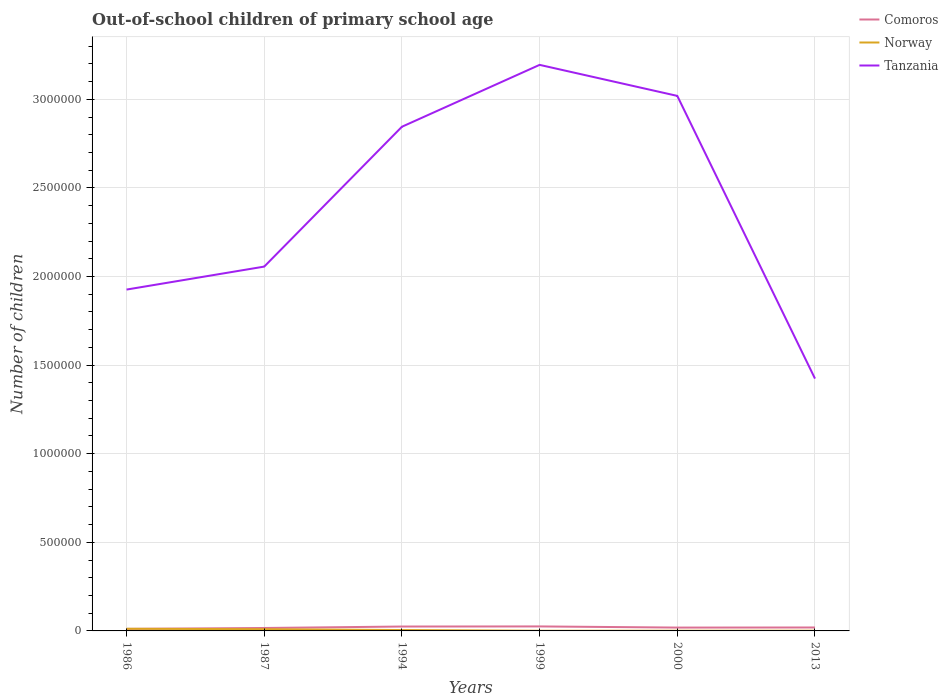Is the number of lines equal to the number of legend labels?
Your response must be concise. Yes. Across all years, what is the maximum number of out-of-school children in Tanzania?
Keep it short and to the point. 1.42e+06. In which year was the number of out-of-school children in Tanzania maximum?
Provide a succinct answer. 2013. What is the total number of out-of-school children in Comoros in the graph?
Offer a very short reply. -2769. What is the difference between the highest and the second highest number of out-of-school children in Tanzania?
Your response must be concise. 1.77e+06. Is the number of out-of-school children in Comoros strictly greater than the number of out-of-school children in Tanzania over the years?
Your response must be concise. Yes. How many lines are there?
Make the answer very short. 3. Does the graph contain grids?
Provide a short and direct response. Yes. How are the legend labels stacked?
Your answer should be compact. Vertical. What is the title of the graph?
Your answer should be very brief. Out-of-school children of primary school age. What is the label or title of the X-axis?
Keep it short and to the point. Years. What is the label or title of the Y-axis?
Offer a very short reply. Number of children. What is the Number of children of Comoros in 1986?
Provide a succinct answer. 1.14e+04. What is the Number of children in Norway in 1986?
Make the answer very short. 1.22e+04. What is the Number of children of Tanzania in 1986?
Offer a very short reply. 1.93e+06. What is the Number of children of Comoros in 1987?
Make the answer very short. 1.66e+04. What is the Number of children in Norway in 1987?
Give a very brief answer. 9681. What is the Number of children in Tanzania in 1987?
Your answer should be very brief. 2.06e+06. What is the Number of children of Comoros in 1994?
Give a very brief answer. 2.48e+04. What is the Number of children in Norway in 1994?
Your answer should be compact. 4983. What is the Number of children in Tanzania in 1994?
Offer a terse response. 2.85e+06. What is the Number of children in Comoros in 1999?
Your response must be concise. 2.54e+04. What is the Number of children in Norway in 1999?
Provide a succinct answer. 908. What is the Number of children in Tanzania in 1999?
Give a very brief answer. 3.19e+06. What is the Number of children in Comoros in 2000?
Provide a short and direct response. 1.89e+04. What is the Number of children of Norway in 2000?
Offer a terse response. 1169. What is the Number of children in Tanzania in 2000?
Keep it short and to the point. 3.02e+06. What is the Number of children in Comoros in 2013?
Offer a very short reply. 1.94e+04. What is the Number of children in Norway in 2013?
Provide a short and direct response. 1232. What is the Number of children in Tanzania in 2013?
Your response must be concise. 1.42e+06. Across all years, what is the maximum Number of children of Comoros?
Provide a succinct answer. 2.54e+04. Across all years, what is the maximum Number of children of Norway?
Your answer should be very brief. 1.22e+04. Across all years, what is the maximum Number of children in Tanzania?
Provide a short and direct response. 3.19e+06. Across all years, what is the minimum Number of children in Comoros?
Your answer should be very brief. 1.14e+04. Across all years, what is the minimum Number of children of Norway?
Ensure brevity in your answer.  908. Across all years, what is the minimum Number of children of Tanzania?
Provide a succinct answer. 1.42e+06. What is the total Number of children of Comoros in the graph?
Offer a very short reply. 1.16e+05. What is the total Number of children in Norway in the graph?
Your answer should be very brief. 3.01e+04. What is the total Number of children of Tanzania in the graph?
Your response must be concise. 1.45e+07. What is the difference between the Number of children of Comoros in 1986 and that in 1987?
Give a very brief answer. -5165. What is the difference between the Number of children in Norway in 1986 and that in 1987?
Offer a terse response. 2478. What is the difference between the Number of children in Tanzania in 1986 and that in 1987?
Provide a succinct answer. -1.30e+05. What is the difference between the Number of children of Comoros in 1986 and that in 1994?
Offer a very short reply. -1.34e+04. What is the difference between the Number of children in Norway in 1986 and that in 1994?
Make the answer very short. 7176. What is the difference between the Number of children in Tanzania in 1986 and that in 1994?
Provide a short and direct response. -9.19e+05. What is the difference between the Number of children in Comoros in 1986 and that in 1999?
Provide a short and direct response. -1.39e+04. What is the difference between the Number of children in Norway in 1986 and that in 1999?
Make the answer very short. 1.13e+04. What is the difference between the Number of children of Tanzania in 1986 and that in 1999?
Your answer should be very brief. -1.27e+06. What is the difference between the Number of children in Comoros in 1986 and that in 2000?
Give a very brief answer. -7472. What is the difference between the Number of children of Norway in 1986 and that in 2000?
Provide a short and direct response. 1.10e+04. What is the difference between the Number of children in Tanzania in 1986 and that in 2000?
Offer a terse response. -1.09e+06. What is the difference between the Number of children of Comoros in 1986 and that in 2013?
Make the answer very short. -7934. What is the difference between the Number of children of Norway in 1986 and that in 2013?
Provide a short and direct response. 1.09e+04. What is the difference between the Number of children of Tanzania in 1986 and that in 2013?
Offer a very short reply. 5.02e+05. What is the difference between the Number of children in Comoros in 1987 and that in 1994?
Provide a succinct answer. -8191. What is the difference between the Number of children in Norway in 1987 and that in 1994?
Ensure brevity in your answer.  4698. What is the difference between the Number of children in Tanzania in 1987 and that in 1994?
Your answer should be compact. -7.89e+05. What is the difference between the Number of children in Comoros in 1987 and that in 1999?
Provide a short and direct response. -8778. What is the difference between the Number of children in Norway in 1987 and that in 1999?
Offer a very short reply. 8773. What is the difference between the Number of children of Tanzania in 1987 and that in 1999?
Your answer should be very brief. -1.14e+06. What is the difference between the Number of children in Comoros in 1987 and that in 2000?
Keep it short and to the point. -2307. What is the difference between the Number of children of Norway in 1987 and that in 2000?
Your answer should be very brief. 8512. What is the difference between the Number of children of Tanzania in 1987 and that in 2000?
Your response must be concise. -9.63e+05. What is the difference between the Number of children of Comoros in 1987 and that in 2013?
Offer a very short reply. -2769. What is the difference between the Number of children in Norway in 1987 and that in 2013?
Offer a terse response. 8449. What is the difference between the Number of children of Tanzania in 1987 and that in 2013?
Your answer should be very brief. 6.32e+05. What is the difference between the Number of children of Comoros in 1994 and that in 1999?
Offer a terse response. -587. What is the difference between the Number of children of Norway in 1994 and that in 1999?
Give a very brief answer. 4075. What is the difference between the Number of children in Tanzania in 1994 and that in 1999?
Offer a very short reply. -3.49e+05. What is the difference between the Number of children of Comoros in 1994 and that in 2000?
Keep it short and to the point. 5884. What is the difference between the Number of children of Norway in 1994 and that in 2000?
Your response must be concise. 3814. What is the difference between the Number of children in Tanzania in 1994 and that in 2000?
Give a very brief answer. -1.74e+05. What is the difference between the Number of children of Comoros in 1994 and that in 2013?
Your answer should be very brief. 5422. What is the difference between the Number of children in Norway in 1994 and that in 2013?
Make the answer very short. 3751. What is the difference between the Number of children of Tanzania in 1994 and that in 2013?
Your response must be concise. 1.42e+06. What is the difference between the Number of children in Comoros in 1999 and that in 2000?
Offer a terse response. 6471. What is the difference between the Number of children of Norway in 1999 and that in 2000?
Ensure brevity in your answer.  -261. What is the difference between the Number of children of Tanzania in 1999 and that in 2000?
Offer a very short reply. 1.75e+05. What is the difference between the Number of children in Comoros in 1999 and that in 2013?
Offer a terse response. 6009. What is the difference between the Number of children in Norway in 1999 and that in 2013?
Ensure brevity in your answer.  -324. What is the difference between the Number of children in Tanzania in 1999 and that in 2013?
Your response must be concise. 1.77e+06. What is the difference between the Number of children of Comoros in 2000 and that in 2013?
Provide a short and direct response. -462. What is the difference between the Number of children of Norway in 2000 and that in 2013?
Give a very brief answer. -63. What is the difference between the Number of children of Tanzania in 2000 and that in 2013?
Your answer should be compact. 1.60e+06. What is the difference between the Number of children in Comoros in 1986 and the Number of children in Norway in 1987?
Your answer should be very brief. 1742. What is the difference between the Number of children in Comoros in 1986 and the Number of children in Tanzania in 1987?
Give a very brief answer. -2.04e+06. What is the difference between the Number of children in Norway in 1986 and the Number of children in Tanzania in 1987?
Your answer should be very brief. -2.04e+06. What is the difference between the Number of children in Comoros in 1986 and the Number of children in Norway in 1994?
Your answer should be compact. 6440. What is the difference between the Number of children of Comoros in 1986 and the Number of children of Tanzania in 1994?
Your response must be concise. -2.83e+06. What is the difference between the Number of children in Norway in 1986 and the Number of children in Tanzania in 1994?
Your answer should be very brief. -2.83e+06. What is the difference between the Number of children in Comoros in 1986 and the Number of children in Norway in 1999?
Provide a short and direct response. 1.05e+04. What is the difference between the Number of children of Comoros in 1986 and the Number of children of Tanzania in 1999?
Ensure brevity in your answer.  -3.18e+06. What is the difference between the Number of children in Norway in 1986 and the Number of children in Tanzania in 1999?
Ensure brevity in your answer.  -3.18e+06. What is the difference between the Number of children in Comoros in 1986 and the Number of children in Norway in 2000?
Provide a short and direct response. 1.03e+04. What is the difference between the Number of children of Comoros in 1986 and the Number of children of Tanzania in 2000?
Keep it short and to the point. -3.01e+06. What is the difference between the Number of children in Norway in 1986 and the Number of children in Tanzania in 2000?
Offer a terse response. -3.01e+06. What is the difference between the Number of children of Comoros in 1986 and the Number of children of Norway in 2013?
Ensure brevity in your answer.  1.02e+04. What is the difference between the Number of children in Comoros in 1986 and the Number of children in Tanzania in 2013?
Offer a terse response. -1.41e+06. What is the difference between the Number of children in Norway in 1986 and the Number of children in Tanzania in 2013?
Provide a succinct answer. -1.41e+06. What is the difference between the Number of children in Comoros in 1987 and the Number of children in Norway in 1994?
Keep it short and to the point. 1.16e+04. What is the difference between the Number of children in Comoros in 1987 and the Number of children in Tanzania in 1994?
Your answer should be very brief. -2.83e+06. What is the difference between the Number of children of Norway in 1987 and the Number of children of Tanzania in 1994?
Make the answer very short. -2.84e+06. What is the difference between the Number of children of Comoros in 1987 and the Number of children of Norway in 1999?
Your response must be concise. 1.57e+04. What is the difference between the Number of children of Comoros in 1987 and the Number of children of Tanzania in 1999?
Offer a very short reply. -3.18e+06. What is the difference between the Number of children of Norway in 1987 and the Number of children of Tanzania in 1999?
Provide a short and direct response. -3.18e+06. What is the difference between the Number of children of Comoros in 1987 and the Number of children of Norway in 2000?
Your response must be concise. 1.54e+04. What is the difference between the Number of children of Comoros in 1987 and the Number of children of Tanzania in 2000?
Keep it short and to the point. -3.00e+06. What is the difference between the Number of children in Norway in 1987 and the Number of children in Tanzania in 2000?
Provide a succinct answer. -3.01e+06. What is the difference between the Number of children in Comoros in 1987 and the Number of children in Norway in 2013?
Offer a very short reply. 1.54e+04. What is the difference between the Number of children in Comoros in 1987 and the Number of children in Tanzania in 2013?
Provide a succinct answer. -1.41e+06. What is the difference between the Number of children of Norway in 1987 and the Number of children of Tanzania in 2013?
Your response must be concise. -1.41e+06. What is the difference between the Number of children of Comoros in 1994 and the Number of children of Norway in 1999?
Offer a terse response. 2.39e+04. What is the difference between the Number of children of Comoros in 1994 and the Number of children of Tanzania in 1999?
Keep it short and to the point. -3.17e+06. What is the difference between the Number of children in Norway in 1994 and the Number of children in Tanzania in 1999?
Make the answer very short. -3.19e+06. What is the difference between the Number of children of Comoros in 1994 and the Number of children of Norway in 2000?
Your response must be concise. 2.36e+04. What is the difference between the Number of children in Comoros in 1994 and the Number of children in Tanzania in 2000?
Keep it short and to the point. -2.99e+06. What is the difference between the Number of children in Norway in 1994 and the Number of children in Tanzania in 2000?
Your answer should be compact. -3.01e+06. What is the difference between the Number of children in Comoros in 1994 and the Number of children in Norway in 2013?
Your answer should be very brief. 2.35e+04. What is the difference between the Number of children of Comoros in 1994 and the Number of children of Tanzania in 2013?
Provide a succinct answer. -1.40e+06. What is the difference between the Number of children in Norway in 1994 and the Number of children in Tanzania in 2013?
Offer a terse response. -1.42e+06. What is the difference between the Number of children of Comoros in 1999 and the Number of children of Norway in 2000?
Your response must be concise. 2.42e+04. What is the difference between the Number of children in Comoros in 1999 and the Number of children in Tanzania in 2000?
Give a very brief answer. -2.99e+06. What is the difference between the Number of children in Norway in 1999 and the Number of children in Tanzania in 2000?
Offer a very short reply. -3.02e+06. What is the difference between the Number of children in Comoros in 1999 and the Number of children in Norway in 2013?
Give a very brief answer. 2.41e+04. What is the difference between the Number of children of Comoros in 1999 and the Number of children of Tanzania in 2013?
Offer a terse response. -1.40e+06. What is the difference between the Number of children of Norway in 1999 and the Number of children of Tanzania in 2013?
Your answer should be very brief. -1.42e+06. What is the difference between the Number of children in Comoros in 2000 and the Number of children in Norway in 2013?
Offer a terse response. 1.77e+04. What is the difference between the Number of children in Comoros in 2000 and the Number of children in Tanzania in 2013?
Make the answer very short. -1.41e+06. What is the difference between the Number of children in Norway in 2000 and the Number of children in Tanzania in 2013?
Keep it short and to the point. -1.42e+06. What is the average Number of children in Comoros per year?
Ensure brevity in your answer.  1.94e+04. What is the average Number of children in Norway per year?
Offer a very short reply. 5022. What is the average Number of children of Tanzania per year?
Ensure brevity in your answer.  2.41e+06. In the year 1986, what is the difference between the Number of children in Comoros and Number of children in Norway?
Offer a terse response. -736. In the year 1986, what is the difference between the Number of children of Comoros and Number of children of Tanzania?
Give a very brief answer. -1.91e+06. In the year 1986, what is the difference between the Number of children of Norway and Number of children of Tanzania?
Keep it short and to the point. -1.91e+06. In the year 1987, what is the difference between the Number of children of Comoros and Number of children of Norway?
Give a very brief answer. 6907. In the year 1987, what is the difference between the Number of children of Comoros and Number of children of Tanzania?
Offer a very short reply. -2.04e+06. In the year 1987, what is the difference between the Number of children of Norway and Number of children of Tanzania?
Your response must be concise. -2.05e+06. In the year 1994, what is the difference between the Number of children in Comoros and Number of children in Norway?
Offer a very short reply. 1.98e+04. In the year 1994, what is the difference between the Number of children of Comoros and Number of children of Tanzania?
Provide a short and direct response. -2.82e+06. In the year 1994, what is the difference between the Number of children of Norway and Number of children of Tanzania?
Your answer should be very brief. -2.84e+06. In the year 1999, what is the difference between the Number of children of Comoros and Number of children of Norway?
Provide a succinct answer. 2.45e+04. In the year 1999, what is the difference between the Number of children in Comoros and Number of children in Tanzania?
Offer a terse response. -3.17e+06. In the year 1999, what is the difference between the Number of children in Norway and Number of children in Tanzania?
Keep it short and to the point. -3.19e+06. In the year 2000, what is the difference between the Number of children of Comoros and Number of children of Norway?
Offer a very short reply. 1.77e+04. In the year 2000, what is the difference between the Number of children of Comoros and Number of children of Tanzania?
Offer a very short reply. -3.00e+06. In the year 2000, what is the difference between the Number of children of Norway and Number of children of Tanzania?
Make the answer very short. -3.02e+06. In the year 2013, what is the difference between the Number of children in Comoros and Number of children in Norway?
Your response must be concise. 1.81e+04. In the year 2013, what is the difference between the Number of children of Comoros and Number of children of Tanzania?
Your response must be concise. -1.40e+06. In the year 2013, what is the difference between the Number of children of Norway and Number of children of Tanzania?
Keep it short and to the point. -1.42e+06. What is the ratio of the Number of children of Comoros in 1986 to that in 1987?
Make the answer very short. 0.69. What is the ratio of the Number of children of Norway in 1986 to that in 1987?
Provide a short and direct response. 1.26. What is the ratio of the Number of children of Tanzania in 1986 to that in 1987?
Your response must be concise. 0.94. What is the ratio of the Number of children of Comoros in 1986 to that in 1994?
Make the answer very short. 0.46. What is the ratio of the Number of children of Norway in 1986 to that in 1994?
Offer a terse response. 2.44. What is the ratio of the Number of children of Tanzania in 1986 to that in 1994?
Your answer should be very brief. 0.68. What is the ratio of the Number of children of Comoros in 1986 to that in 1999?
Your answer should be very brief. 0.45. What is the ratio of the Number of children of Norway in 1986 to that in 1999?
Provide a short and direct response. 13.39. What is the ratio of the Number of children in Tanzania in 1986 to that in 1999?
Provide a short and direct response. 0.6. What is the ratio of the Number of children in Comoros in 1986 to that in 2000?
Provide a short and direct response. 0.6. What is the ratio of the Number of children in Norway in 1986 to that in 2000?
Your response must be concise. 10.4. What is the ratio of the Number of children of Tanzania in 1986 to that in 2000?
Keep it short and to the point. 0.64. What is the ratio of the Number of children of Comoros in 1986 to that in 2013?
Your response must be concise. 0.59. What is the ratio of the Number of children of Norway in 1986 to that in 2013?
Make the answer very short. 9.87. What is the ratio of the Number of children in Tanzania in 1986 to that in 2013?
Keep it short and to the point. 1.35. What is the ratio of the Number of children in Comoros in 1987 to that in 1994?
Ensure brevity in your answer.  0.67. What is the ratio of the Number of children in Norway in 1987 to that in 1994?
Keep it short and to the point. 1.94. What is the ratio of the Number of children in Tanzania in 1987 to that in 1994?
Offer a terse response. 0.72. What is the ratio of the Number of children in Comoros in 1987 to that in 1999?
Your answer should be very brief. 0.65. What is the ratio of the Number of children in Norway in 1987 to that in 1999?
Provide a succinct answer. 10.66. What is the ratio of the Number of children in Tanzania in 1987 to that in 1999?
Make the answer very short. 0.64. What is the ratio of the Number of children of Comoros in 1987 to that in 2000?
Offer a terse response. 0.88. What is the ratio of the Number of children of Norway in 1987 to that in 2000?
Offer a very short reply. 8.28. What is the ratio of the Number of children of Tanzania in 1987 to that in 2000?
Your response must be concise. 0.68. What is the ratio of the Number of children in Comoros in 1987 to that in 2013?
Your response must be concise. 0.86. What is the ratio of the Number of children in Norway in 1987 to that in 2013?
Keep it short and to the point. 7.86. What is the ratio of the Number of children of Tanzania in 1987 to that in 2013?
Keep it short and to the point. 1.44. What is the ratio of the Number of children of Comoros in 1994 to that in 1999?
Provide a short and direct response. 0.98. What is the ratio of the Number of children in Norway in 1994 to that in 1999?
Your answer should be very brief. 5.49. What is the ratio of the Number of children of Tanzania in 1994 to that in 1999?
Your answer should be compact. 0.89. What is the ratio of the Number of children in Comoros in 1994 to that in 2000?
Offer a terse response. 1.31. What is the ratio of the Number of children of Norway in 1994 to that in 2000?
Offer a very short reply. 4.26. What is the ratio of the Number of children in Tanzania in 1994 to that in 2000?
Your answer should be compact. 0.94. What is the ratio of the Number of children of Comoros in 1994 to that in 2013?
Provide a succinct answer. 1.28. What is the ratio of the Number of children in Norway in 1994 to that in 2013?
Make the answer very short. 4.04. What is the ratio of the Number of children of Tanzania in 1994 to that in 2013?
Your response must be concise. 2. What is the ratio of the Number of children of Comoros in 1999 to that in 2000?
Your response must be concise. 1.34. What is the ratio of the Number of children in Norway in 1999 to that in 2000?
Offer a very short reply. 0.78. What is the ratio of the Number of children of Tanzania in 1999 to that in 2000?
Keep it short and to the point. 1.06. What is the ratio of the Number of children in Comoros in 1999 to that in 2013?
Keep it short and to the point. 1.31. What is the ratio of the Number of children of Norway in 1999 to that in 2013?
Ensure brevity in your answer.  0.74. What is the ratio of the Number of children of Tanzania in 1999 to that in 2013?
Your answer should be very brief. 2.24. What is the ratio of the Number of children of Comoros in 2000 to that in 2013?
Your answer should be very brief. 0.98. What is the ratio of the Number of children of Norway in 2000 to that in 2013?
Make the answer very short. 0.95. What is the ratio of the Number of children in Tanzania in 2000 to that in 2013?
Provide a short and direct response. 2.12. What is the difference between the highest and the second highest Number of children in Comoros?
Keep it short and to the point. 587. What is the difference between the highest and the second highest Number of children of Norway?
Provide a succinct answer. 2478. What is the difference between the highest and the second highest Number of children of Tanzania?
Ensure brevity in your answer.  1.75e+05. What is the difference between the highest and the lowest Number of children of Comoros?
Your answer should be compact. 1.39e+04. What is the difference between the highest and the lowest Number of children in Norway?
Make the answer very short. 1.13e+04. What is the difference between the highest and the lowest Number of children in Tanzania?
Make the answer very short. 1.77e+06. 